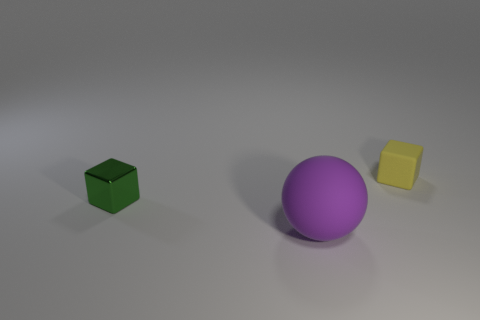Add 1 metallic cylinders. How many objects exist? 4 Subtract all cubes. How many objects are left? 1 Subtract all purple balls. How many green blocks are left? 1 Add 1 brown metal blocks. How many brown metal blocks exist? 1 Subtract all yellow blocks. How many blocks are left? 1 Subtract 0 yellow balls. How many objects are left? 3 Subtract 1 balls. How many balls are left? 0 Subtract all green spheres. Subtract all green blocks. How many spheres are left? 1 Subtract all blocks. Subtract all gray matte balls. How many objects are left? 1 Add 1 green metallic blocks. How many green metallic blocks are left? 2 